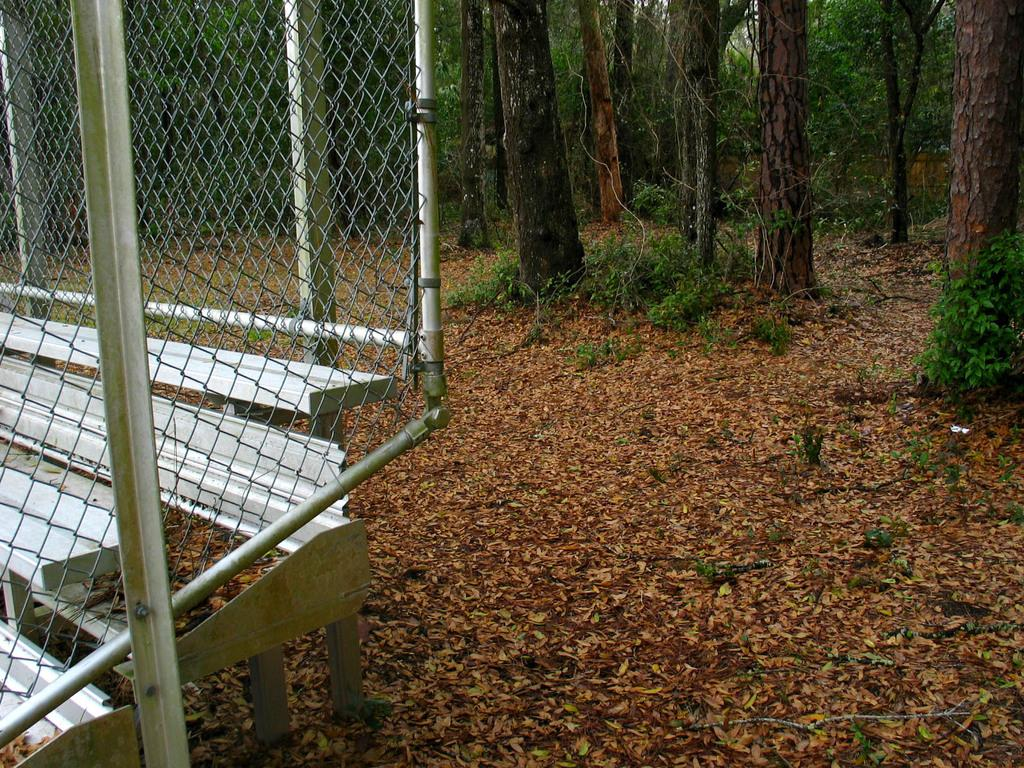What is located on the left side of the image? There is a fencing on the left side of the image. What can be seen on the ground in the image? There are dry leaves and plants on the ground in the image. What type of vegetation is present in the image? There are plants and trees on the ground in the image. What can be seen in the background of the image? There are trees visible in the background of the image. Where is the lunchroom located in the image? There is no lunchroom present in the image. What type of cattle can be seen grazing in the image? There are no cattle present in the image. 